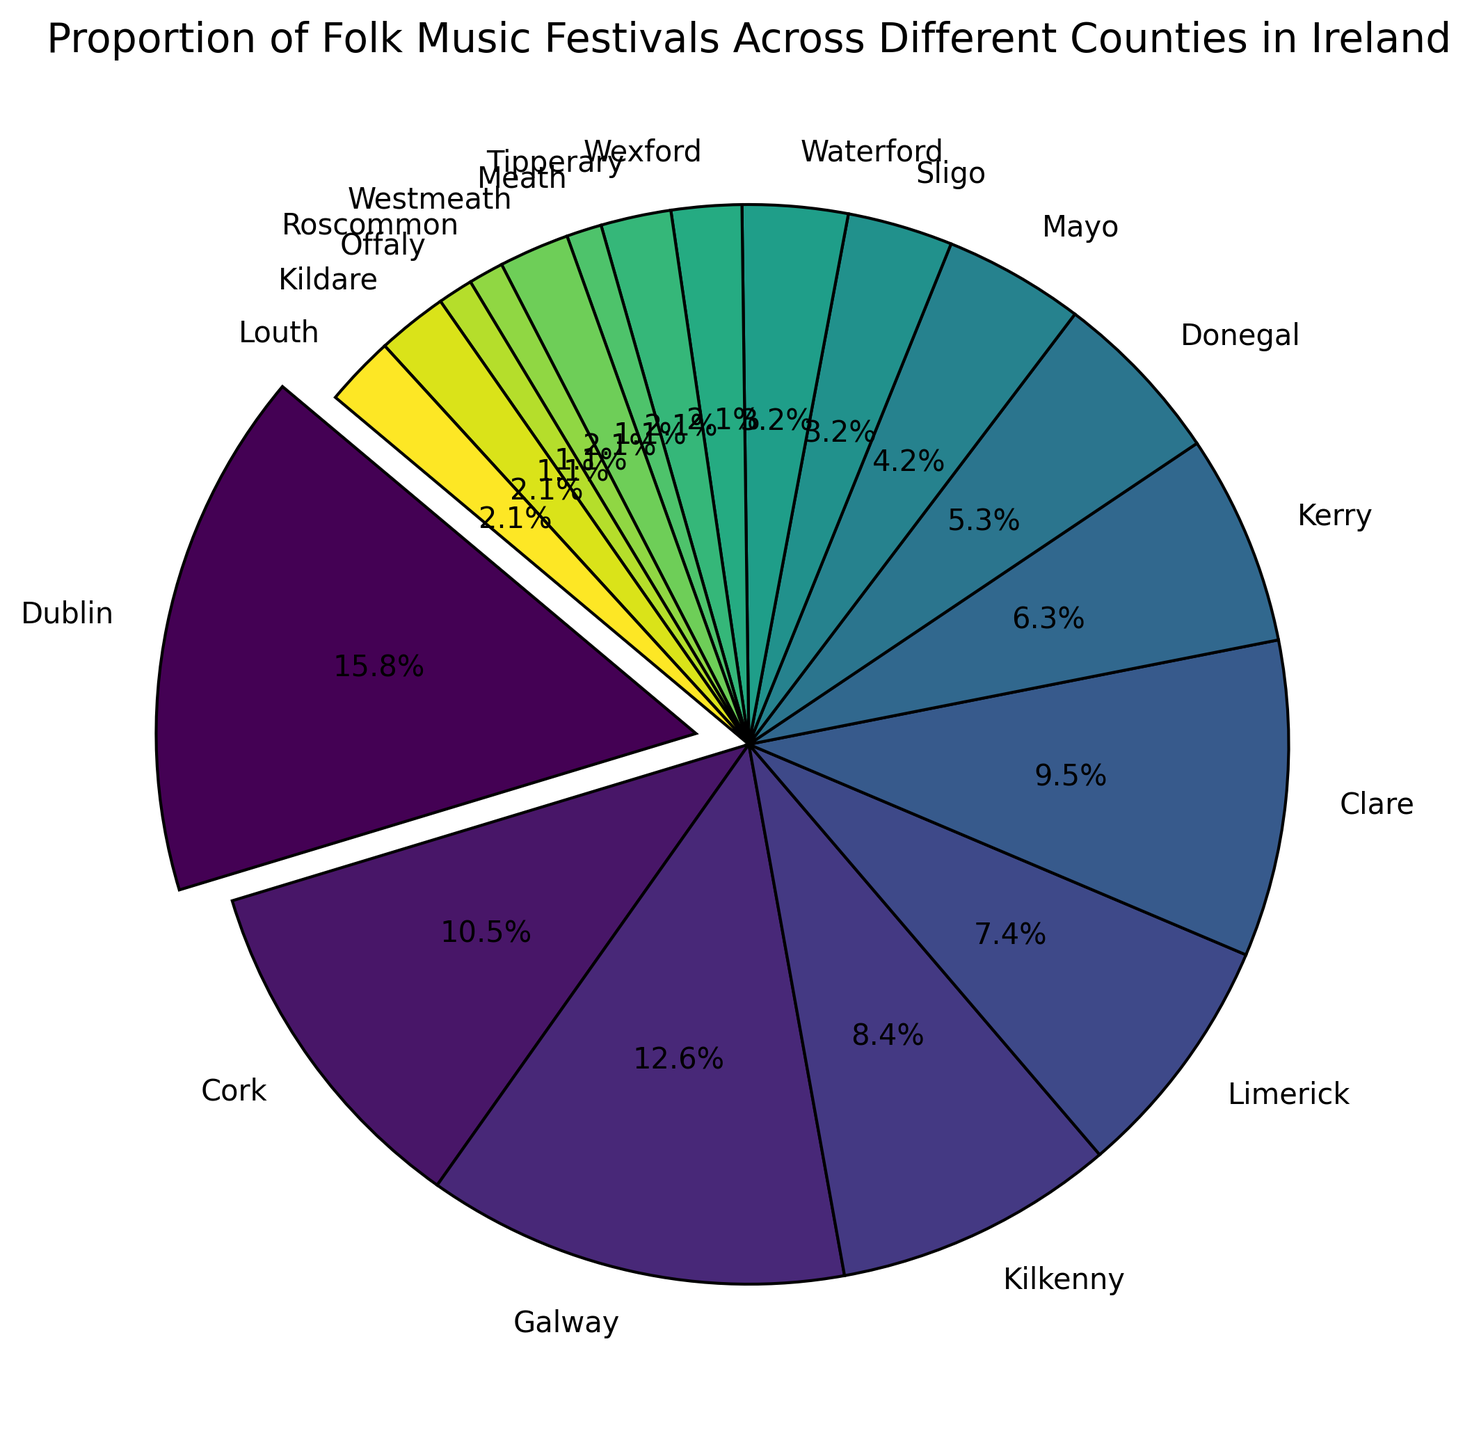Which county has the highest proportion of folk music festivals? The slice with the largest proportion is highlighted by being slightly exploded outward. This slice corresponds to Dublin.
Answer: Dublin Which two counties have the least number of folk music festivals? The smallest slices in the pie chart correspond to Roscommon and Offaly, each with a very small percentage of the total.
Answer: Roscommon and Offaly What is the combined percentage of folk music festivals held in Cork and Galway? We need to add the percentages for Cork and Galway. Cork has 10 festivals and Galway has 12. The total number of festivals is 95. Therefore, the combined percentage is (10/95) + (12/95) = 0.105 + 0.126 = 0.231, or 23.1%.
Answer: 23.1% Are there more folk music festivals in Limerick or in Clare? By comparing their slices, the slice for Clare is slightly larger than the slice for Limerick.
Answer: Clare How many counties have exactly 2 folk music festivals? By observing the labels, we see that Wexford, Tipperary, Kildare, Meath, Westmeath, and Louth each have 2 festivals.
Answer: 6 counties What is the overall proportion of folk music festivals held in counties with fewer than 5 festivals each? We sum up the festival counts for counties with fewer than 5 festivals: Mayo (4), Sligo (3), Waterford (3), Wexford (2), Tipperary (2), Meath (2), Roscommon (1), Offaly (1), Kildare (2), Louth (2). The total is 22. The proportion is 22/95, approximately 0.2316, or 23.2%.
Answer: 23.2% Which county has a larger share of the folk music festivals: Kerry or Donegal? Comparing their slices visually, Kerry's slice is larger than Donegal's slice.
Answer: Kerry How many festivals are held in counties with slices of similar sizes to Wexford in the pie chart? Wexford has 2 festivals. Other counties with the same number, observed by looking for slices of a similar size, are Tipperary, Meath, Kildare, Louth, and Westmeath. Each of these counties also has 2 festivals.
Answer: 5 festivals What fraction of the total festivals are held in Dublin? Dublin's slice is highlighted and corresponds to 15 out of the total of 95 festivals. The fraction is 15/95.
Answer: 15/95 Which counties have festival counts exactly one less than Galway? Galway has 12 festivals. Counties with 11 festivals do not exist in the dataset.
Answer: None 